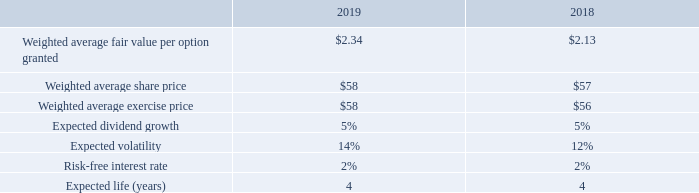ASSUMPTIONS USED IN STOCK OPTION PRICING MODEL
The fair value of options granted was determined using a variation of a binomial option pricing model that takes into account factors specific to the share incentive plans, such as the vesting period. The following table shows the principal assumptions used in the valuation.
Expected dividend growth is commensurate with BCE’s dividend growth strategy. Expected volatility is based on the historical volatility of BCE’s share price. The risk-free rate used is equal to the yield available on Government of Canada bonds at the date of grant with a term equal to the expected life of the options
How is the fair value of options granted determined? Using a variation of a binomial option pricing model that takes into account factors specific to the share incentive plans, such as the vesting period. What is expected volatility based on? The historical volatility of bce’s share price. Which assumption variables in the table are further elaborated in the text? Expected dividend growth, expected volatility, risk-free interest rate. In which year is the weighted average share price higher? $58>$57
Answer: 2019. What is the change in the expected volatility in 2019?
Answer scale should be: percent. 14%-12%
Answer: 2. What is the average expected life over 2018 and 2019? (4+4)/2
Answer: 4. 